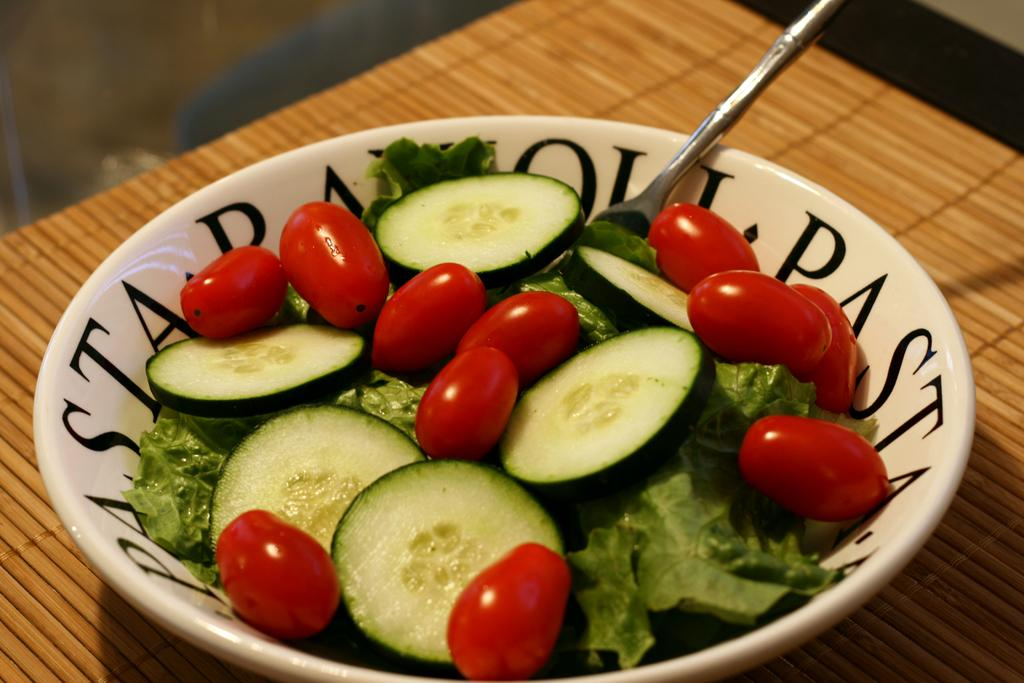What is in the bowl that is visible in the image? The bowl contains slices of cucumber and cherries. What utensil is present in the image? There is a spoon in the image. Where is the bowl located in the image? The bowl is on a table in the image. What is placed under the bowl on the table? There is a table mat on the table. What disease is being discussed in the image? There is no discussion or mention of any disease in the image. 